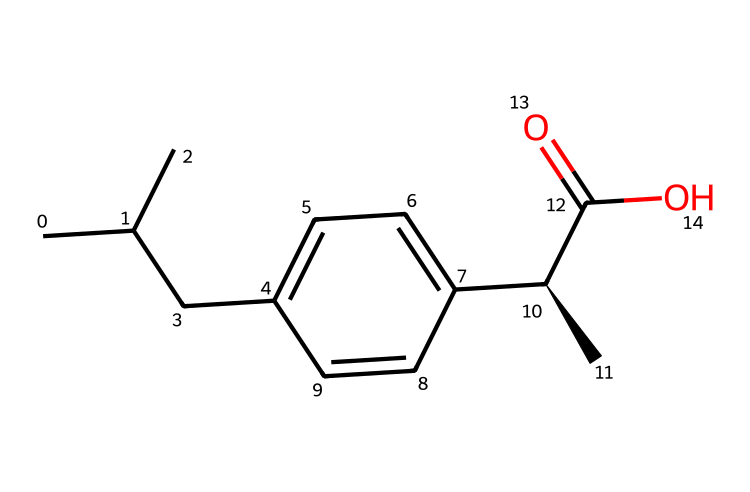What is the molecular formula of ibuprofen? Counting the number of each type of atom in the SMILES representation, there are 13 carbon (C) atoms, 18 hydrogen (H) atoms, and 2 oxygen (O) atoms. Thus, the molecular formula is C13H18O2.
Answer: C13H18O2 How many rings are present in the ibuprofen structure? Observing the SMILES representation, there is one aromatic ring (the benzene-like structure) indicated by the 'c' and parentheses in the SMILES.
Answer: 1 What functional group is present in ibuprofen? The presence of the "-C(=O)O" part in the SMILES indicates a carboxylic acid group, which denotes that ibuprofen has functional characteristics of being acidic.
Answer: carboxylic acid What type of stereochemistry is present in ibuprofen? The notation "[C@H]" in the SMILES indicates that this carbon atom is a chiral center, meaning the molecule can exist in two enantiomeric forms.
Answer: chiral center How many total atoms are in ibuprofen? Adding up all the atoms present in the molecule from the molecular formula, there are 13 (C) + 18 (H) + 2 (O), resulting in a total of 33 atoms.
Answer: 33 What type of chemical is ibuprofen classified as? Given that ibuprofen contains a carboxylic acid group and is used primarily as a pain reliever, it is classified as a nonsteroidal anti-inflammatory drug.
Answer: nonsteroidal anti-inflammatory drug 